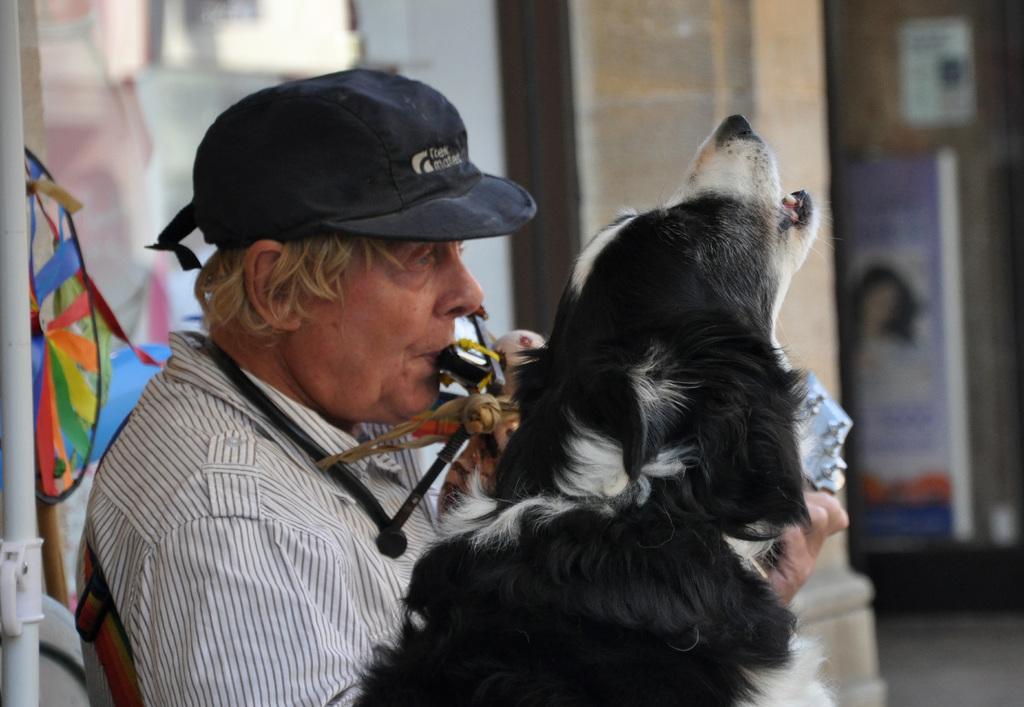Could you give a brief overview of what you see in this image? In this picture, there is a man and a dog here. The man is holding something in his mouth. He's wearing a cap. In the background there is a pillar. 